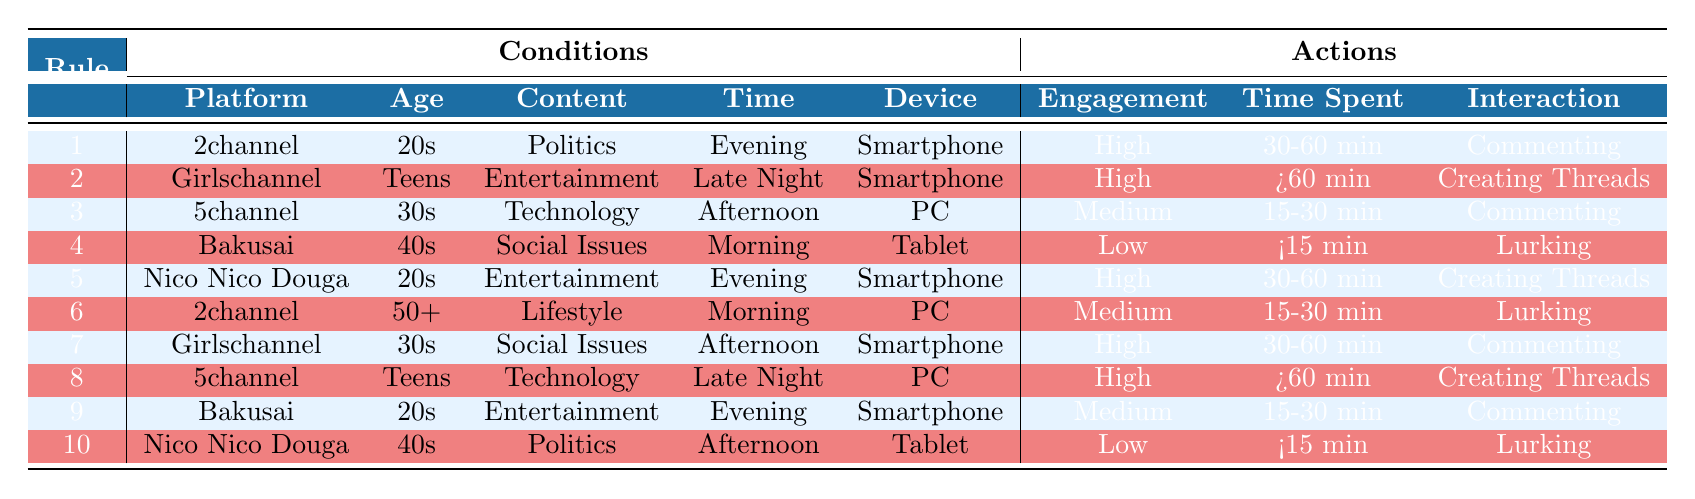What is the user engagement level for users on Girlschannel who are teens? Referring to the table, the conditions for Girlschannel with the age group "Teens" shows a user engagement level of "High" in row 2.
Answer: High Which platform shows low user engagement among users in their 40s discussing social issues? According to row 4 in the table, Bakusai has "Low" user engagement for users in their 40s discussing social issues, providing a direct match to the question.
Answer: Bakusai What is the average time spent by users on 5channel in their 30s discussing technology? By examining row 3, the average time spent for users on 5channel in their 30s discussing technology is "15-30 min". As there’s only one entry in this category, this is also the average.
Answer: 15-30 min Are users on 2channel who are in their 50s and use a PC more likely to engage in lurking than commenting? Looking at row 6, the engagement type for users on 2channel who are in their 50s using a PC is "Lurking", while there's no result for "Commenting." Therefore, yes, they are more likely to engage in lurking.
Answer: Yes What is the overall trend of user engagement level by age group across the platforms? By analyzing the table, we note that engagement varies by age. Users in their 20s and teens often have "High" engagement levels, while users in their 40s and 50s have either "Low" or "Medium" engagement levels, indicating youth is more engaged.
Answer: Youth are more engaged 